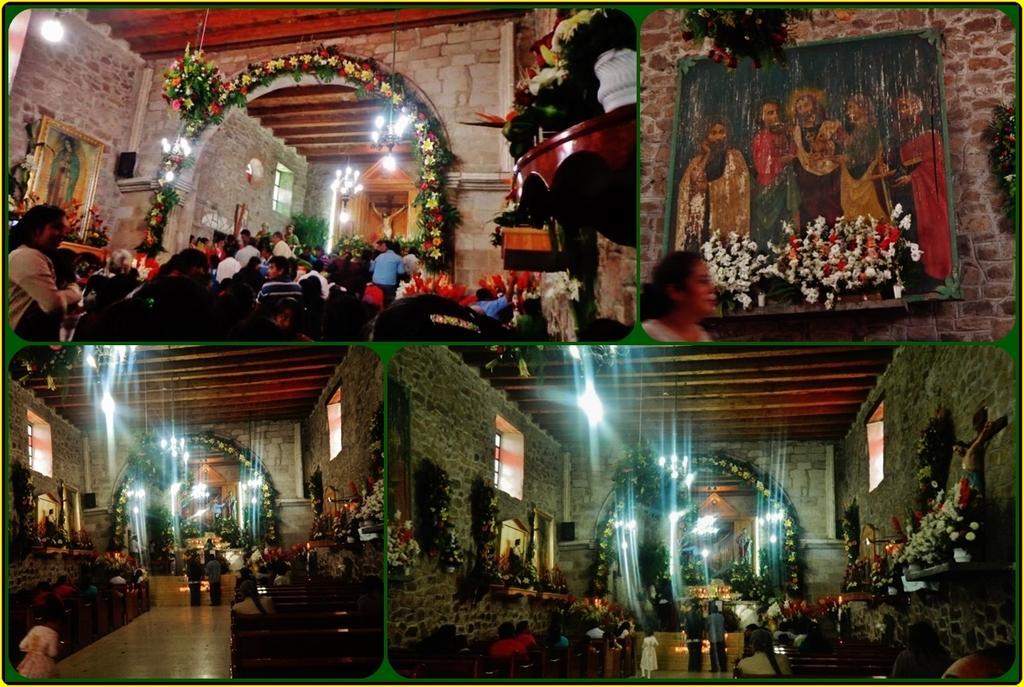Could you give a brief overview of what you see in this image? This is a collage image and here we can see flower bouquets, flower pots, people, boards, lights, benches, windows and there is a wall. 